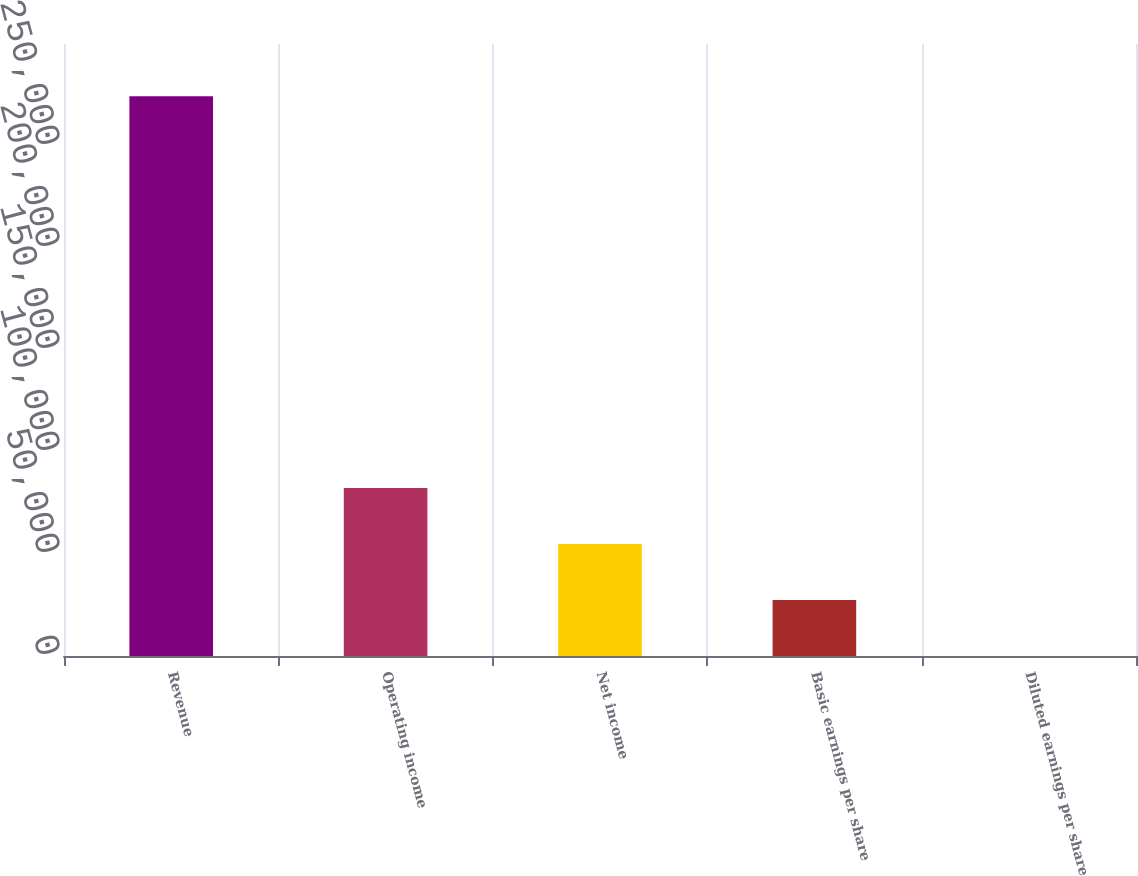Convert chart. <chart><loc_0><loc_0><loc_500><loc_500><bar_chart><fcel>Revenue<fcel>Operating income<fcel>Net income<fcel>Basic earnings per share<fcel>Diluted earnings per share<nl><fcel>274346<fcel>82304.2<fcel>54869.7<fcel>27435.1<fcel>0.6<nl></chart> 